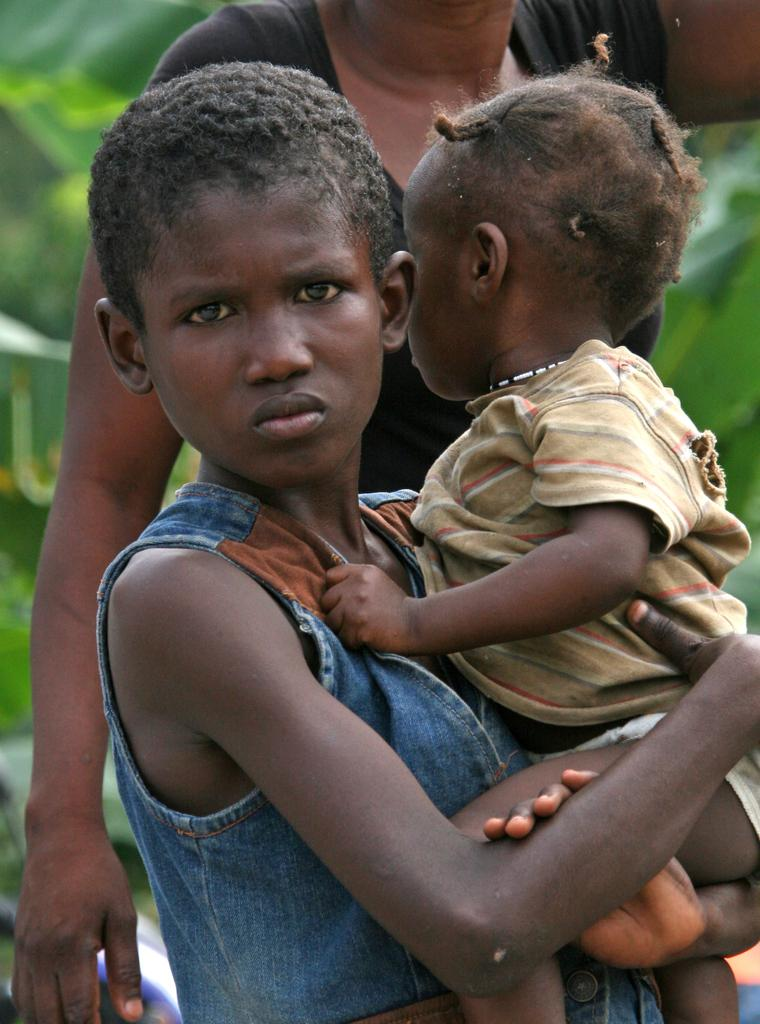What is the person in the image wearing? The person is wearing a blue and brown colored dress in the image. What is the person holding in the image? The person is standing and holding a baby. Can you describe the background of the image? There is another person in the background of the image, and trees are visible. What type of car is parked in the room in the image? There is no car present in the image, and the setting does not appear to be a room. 